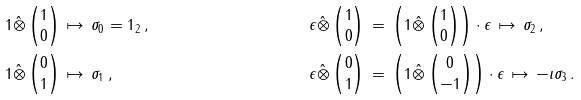Convert formula to latex. <formula><loc_0><loc_0><loc_500><loc_500>& 1 \hat { \otimes } \begin{pmatrix} 1 \\ 0 \end{pmatrix} \, \mapsto \, \sigma _ { 0 } = 1 _ { 2 } \, , & & \epsilon \hat { \otimes } \begin{pmatrix} 1 \\ 0 \end{pmatrix} \, = \, \left ( 1 \hat { \otimes } \begin{pmatrix} 1 \\ 0 \end{pmatrix} \right ) \cdot \epsilon \, \mapsto \, \sigma _ { 2 } \, , \\ & 1 \hat { \otimes } \begin{pmatrix} 0 \\ 1 \end{pmatrix} \, \mapsto \, \sigma _ { 1 } \, , & & \epsilon \hat { \otimes } \begin{pmatrix} 0 \\ 1 \end{pmatrix} \, = \, \left ( 1 \hat { \otimes } \begin{pmatrix} 0 \\ - 1 \end{pmatrix} \right ) \cdot \epsilon \, \mapsto \, - \imath \sigma _ { 3 } \, .</formula> 